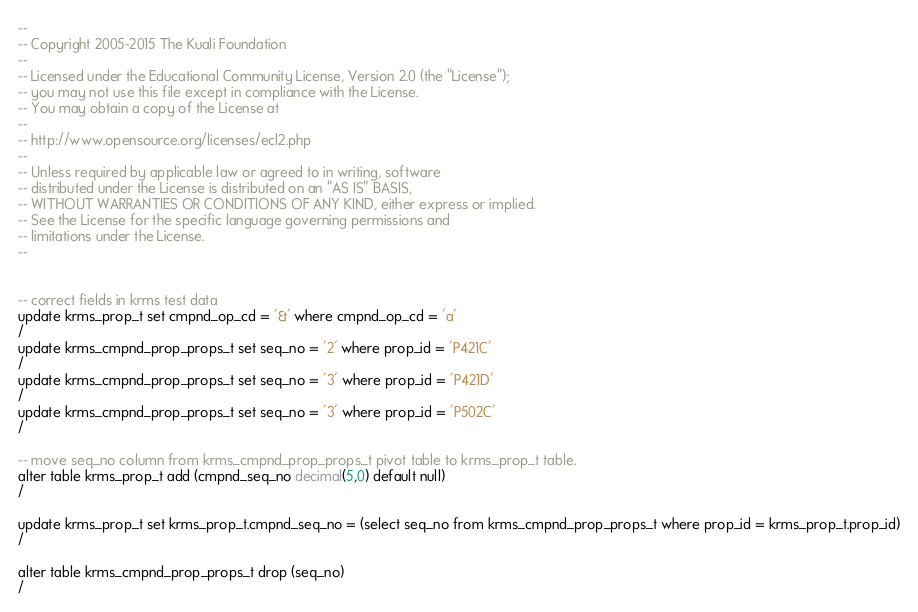<code> <loc_0><loc_0><loc_500><loc_500><_SQL_>--
-- Copyright 2005-2015 The Kuali Foundation
--
-- Licensed under the Educational Community License, Version 2.0 (the "License");
-- you may not use this file except in compliance with the License.
-- You may obtain a copy of the License at
--
-- http://www.opensource.org/licenses/ecl2.php
--
-- Unless required by applicable law or agreed to in writing, software
-- distributed under the License is distributed on an "AS IS" BASIS,
-- WITHOUT WARRANTIES OR CONDITIONS OF ANY KIND, either express or implied.
-- See the License for the specific language governing permissions and
-- limitations under the License.
--


-- correct fields in krms test data
update krms_prop_t set cmpnd_op_cd = '&' where cmpnd_op_cd = 'a'
/
update krms_cmpnd_prop_props_t set seq_no = '2' where prop_id = 'P421C'
/
update krms_cmpnd_prop_props_t set seq_no = '3' where prop_id = 'P421D'
/
update krms_cmpnd_prop_props_t set seq_no = '3' where prop_id = 'P502C'
/

-- move seq_no column from krms_cmpnd_prop_props_t pivot table to krms_prop_t table.
alter table krms_prop_t add (cmpnd_seq_no decimal(5,0) default null)
/

update krms_prop_t set krms_prop_t.cmpnd_seq_no = (select seq_no from krms_cmpnd_prop_props_t where prop_id = krms_prop_t.prop_id)
/

alter table krms_cmpnd_prop_props_t drop (seq_no)
/
</code> 